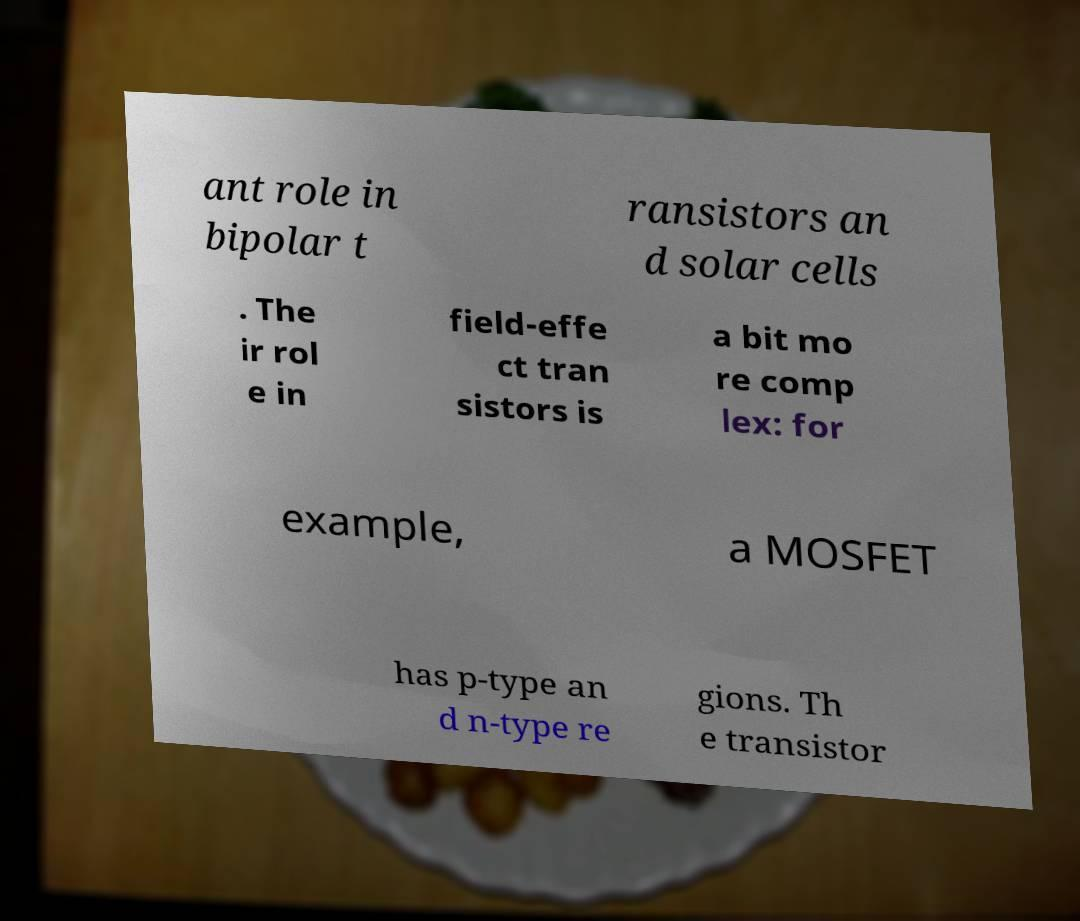For documentation purposes, I need the text within this image transcribed. Could you provide that? ant role in bipolar t ransistors an d solar cells . The ir rol e in field-effe ct tran sistors is a bit mo re comp lex: for example, a MOSFET has p-type an d n-type re gions. Th e transistor 